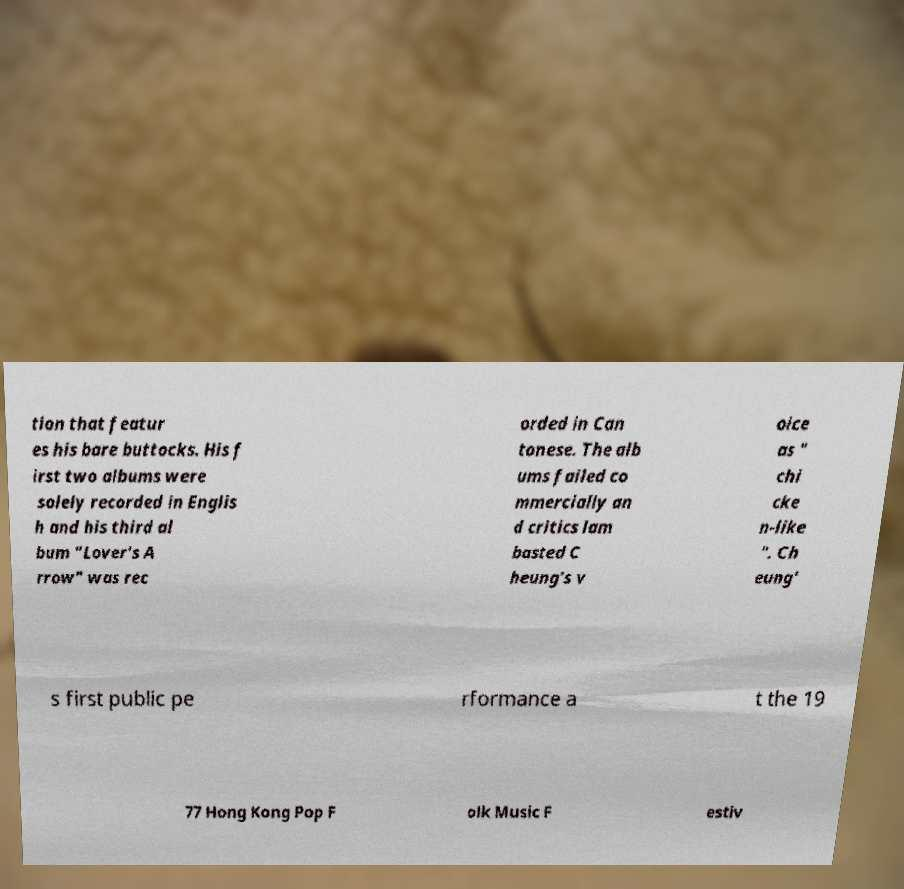There's text embedded in this image that I need extracted. Can you transcribe it verbatim? tion that featur es his bare buttocks. His f irst two albums were solely recorded in Englis h and his third al bum "Lover's A rrow" was rec orded in Can tonese. The alb ums failed co mmercially an d critics lam basted C heung's v oice as " chi cke n-like ". Ch eung' s first public pe rformance a t the 19 77 Hong Kong Pop F olk Music F estiv 